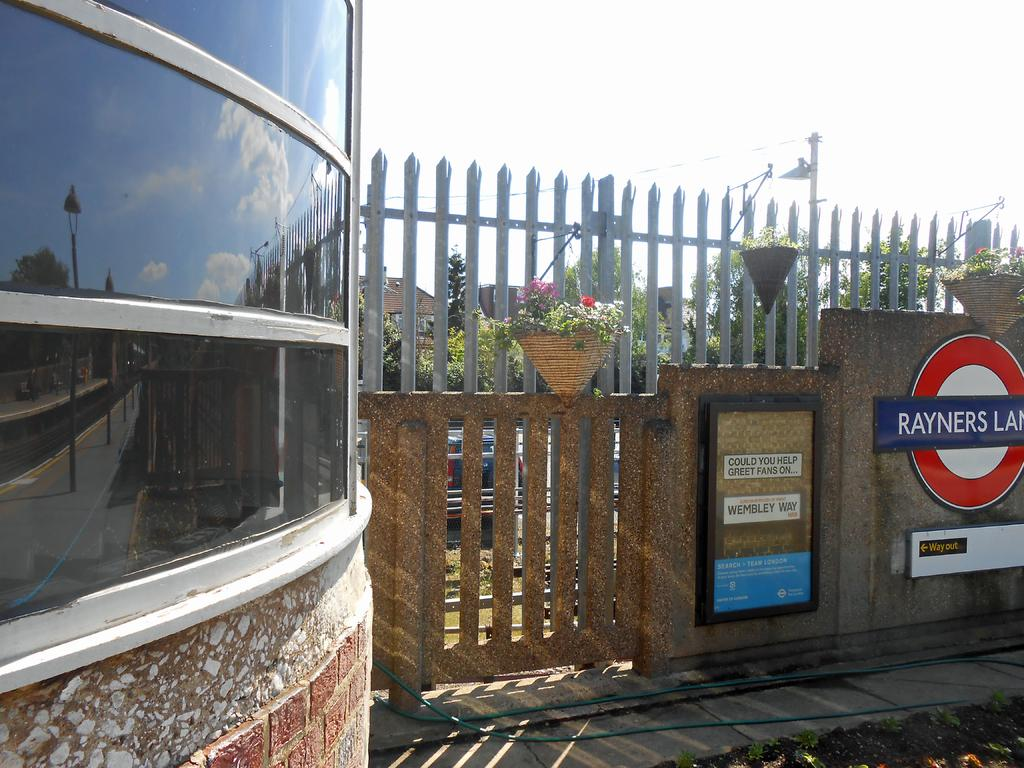What type of structures can be seen in the image? There are buildings in the image. Can you describe a specific feature of the wall in the image? The wall has boards with text on them. What type of vegetation is present in the image? There are plants and trees in the image. What is parked in the image? There is a car parked in the image. What else can be seen in the image that is not a structure or vegetation? There is a pole in the image. How would you describe the weather in the image? The sky is cloudy in the image. What type of chin can be seen on the government official in the image? There is no government official or chin present in the image. Is there a baseball game happening in the image? There is no baseball game or any reference to baseball in the image. 